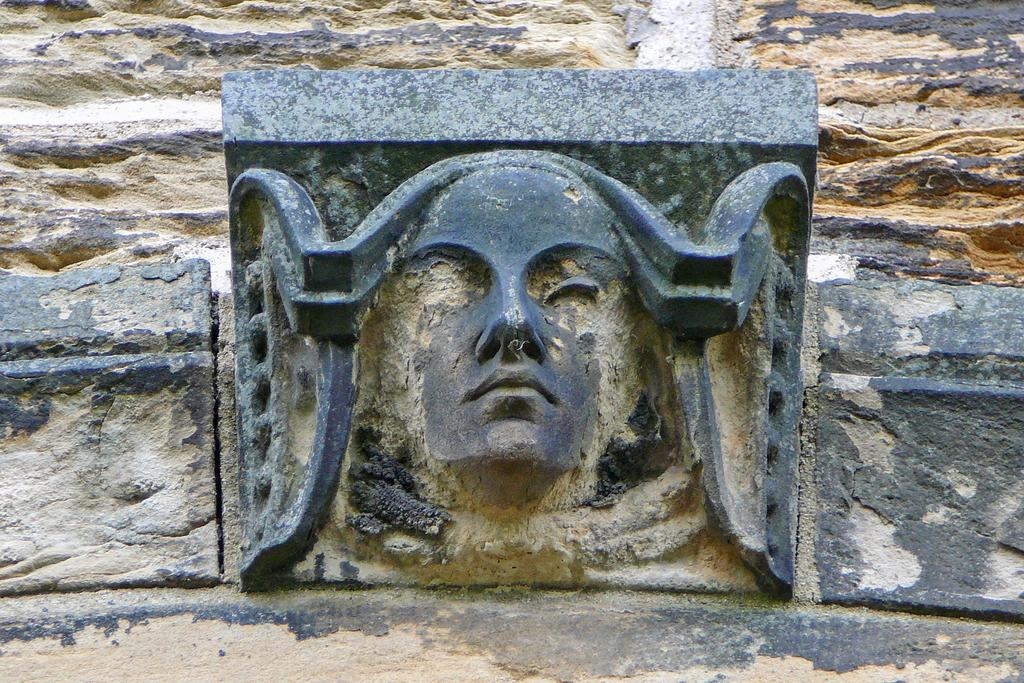What is the main subject of the image? There is a statue in the image. Can you describe the statue? The statue is human-shaped. How many buns are on the statue's head in the image? There are no buns present on the statue's head in the image. What type of mice can be seen interacting with the statue in the image? There are no mice present in the image; it only features a statue. 